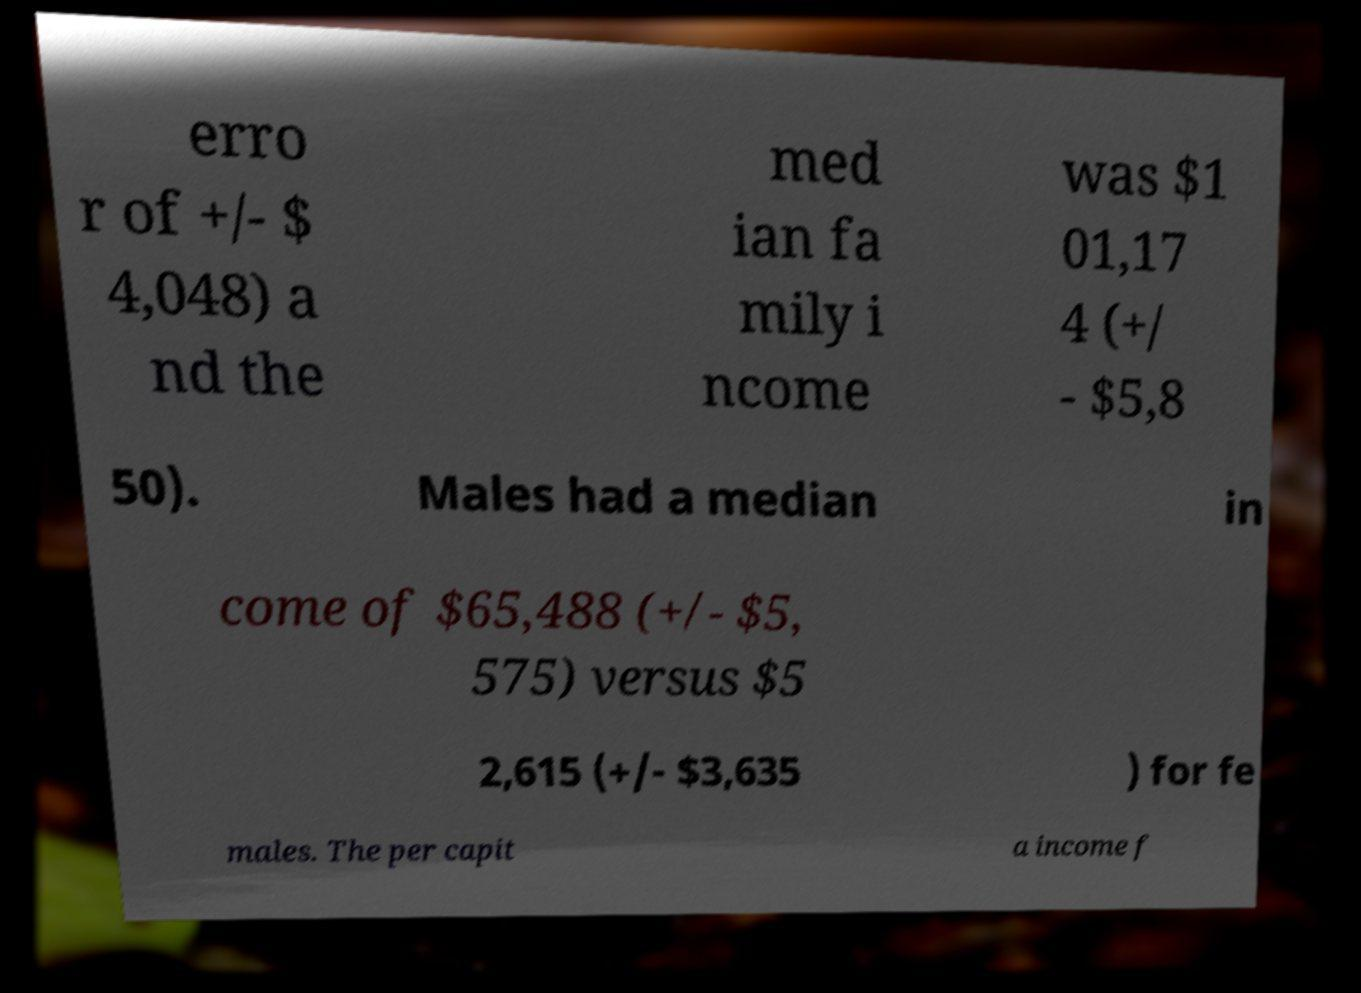I need the written content from this picture converted into text. Can you do that? erro r of +/- $ 4,048) a nd the med ian fa mily i ncome was $1 01,17 4 (+/ - $5,8 50). Males had a median in come of $65,488 (+/- $5, 575) versus $5 2,615 (+/- $3,635 ) for fe males. The per capit a income f 